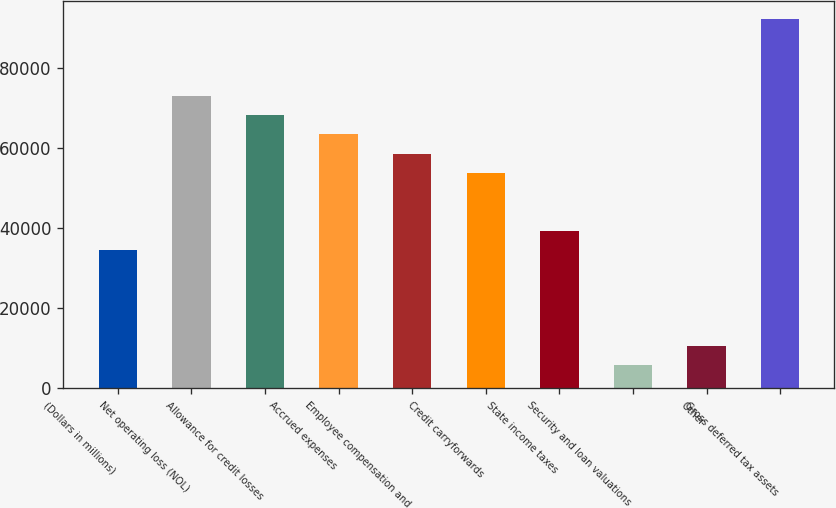<chart> <loc_0><loc_0><loc_500><loc_500><bar_chart><fcel>(Dollars in millions)<fcel>Net operating loss (NOL)<fcel>Allowance for credit losses<fcel>Accrued expenses<fcel>Employee compensation and<fcel>Credit carryforwards<fcel>State income taxes<fcel>Security and loan valuations<fcel>Other<fcel>Gross deferred tax assets<nl><fcel>34616.3<fcel>72991.5<fcel>68194.6<fcel>63397.7<fcel>58600.8<fcel>53803.9<fcel>39413.2<fcel>5834.9<fcel>10631.8<fcel>92179.1<nl></chart> 